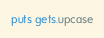Convert code to text. <code><loc_0><loc_0><loc_500><loc_500><_Ruby_>puts gets.upcase

</code> 